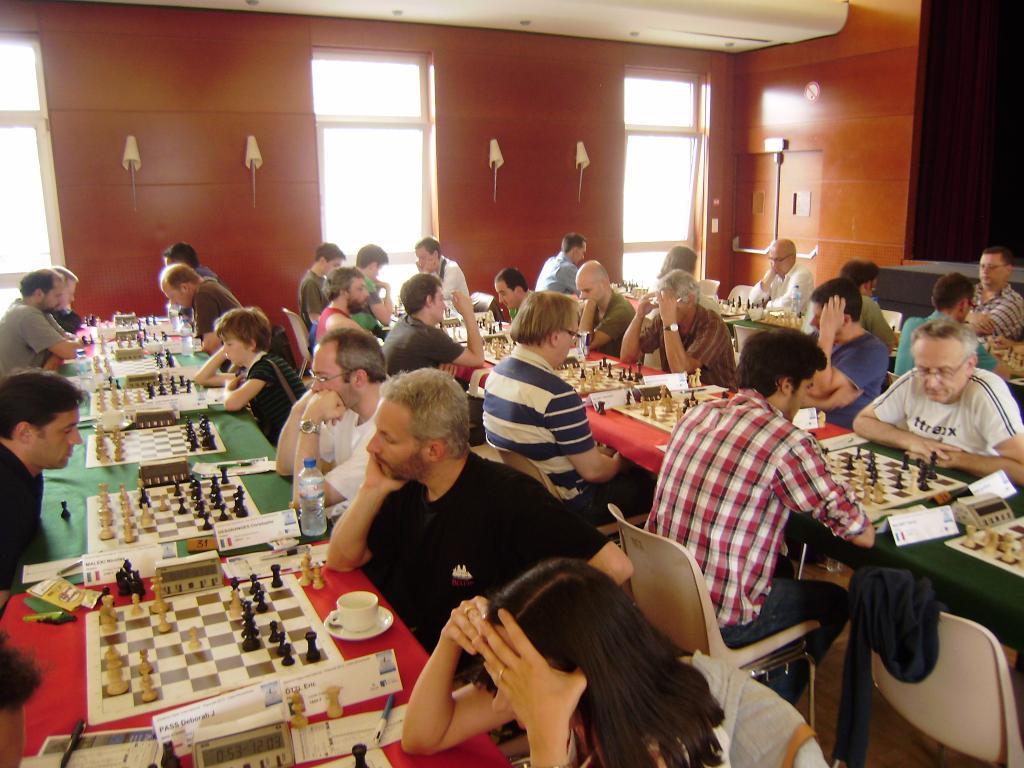Could you give a brief overview of what you see in this image? In this picture we can see some persons are sitting on the chairs. This is table. On the table there are chess boards, cup, and a bottle. On the background there is a wall and this is window. 